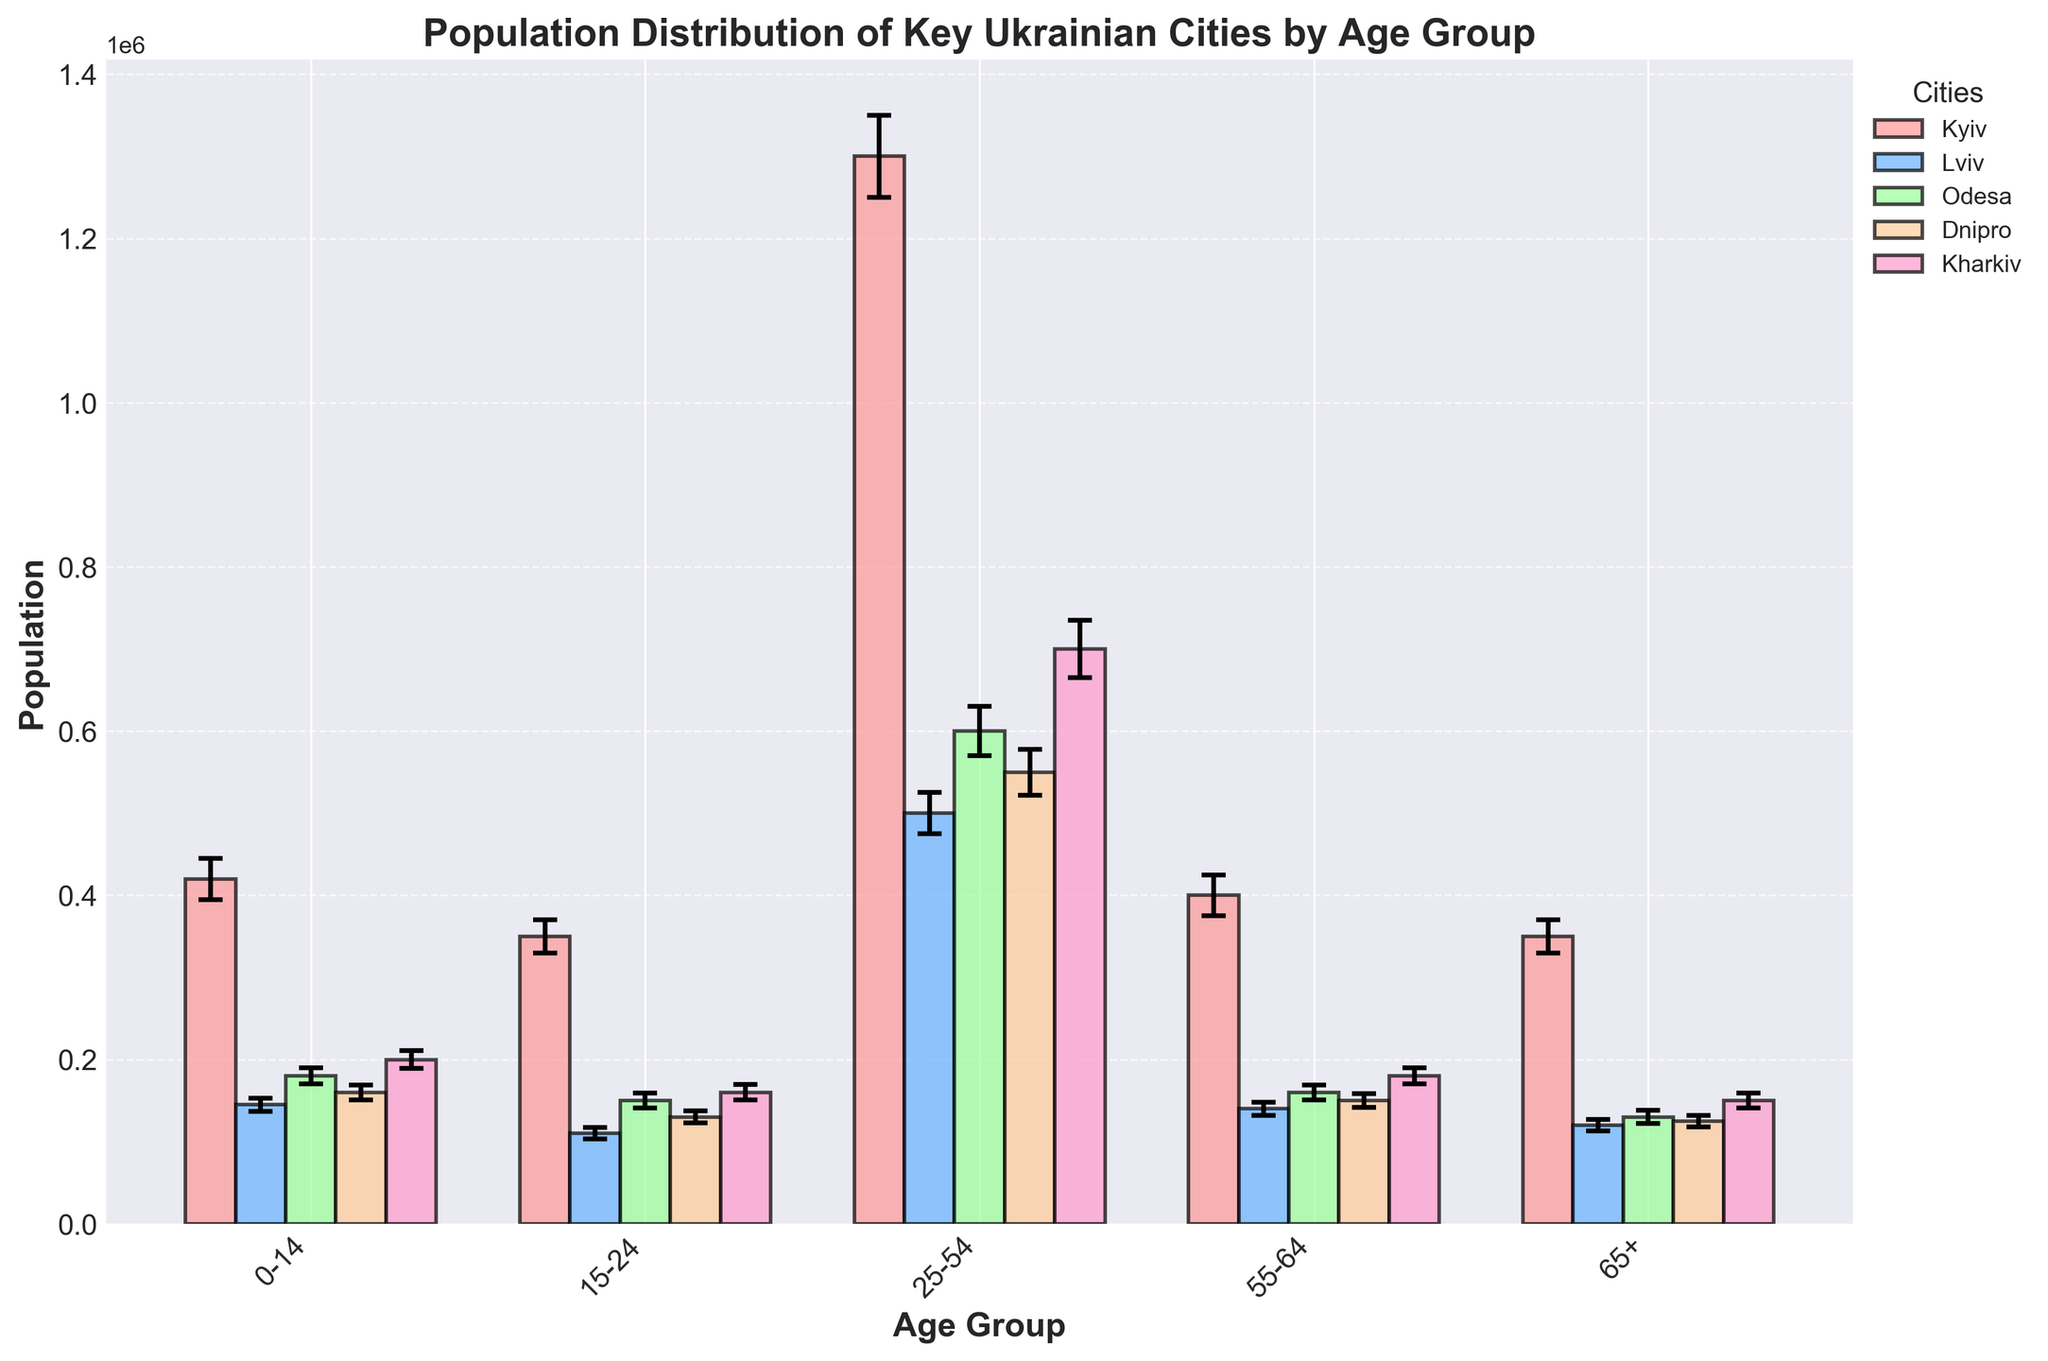what is the title of the plot? Look at the top center of the figure to find the title. The title is "Population Distribution of Key Ukrainian Cities by Age Group"
Answer: Population Distribution of Key Ukrainian Cities by Age Group How many cities are represented in the plot? Identify all unique labels in the legend on the right side of the figure. The cities represented are Kyiv, Lviv, Odesa, Dnipro, and Kharkiv
Answer: 5 Which age group in Kyiv has the highest population? Find the bar corresponding to Kyiv for each age group and compare their heights. The 25-54 age group bar is the tallest among all age groups for Kyiv
Answer: 25-54 Which city has the largest error margin for the 15-24 age group? Look at the error bars on the 15-24 age group across all cities. The largest error bar is for Kharkiv
Answer: Kharkiv What is the approximate population of the 0-14 age group in Lviv? Locate the bar representing Lviv for the 0-14 age group, near the left side of the figure. The height of the bar indicates a population around 145,000
Answer: 145,000 Compare the population of the 55-64 age group between Dnipro and Odesa. Which city has a larger population for this age group? Observe and compare the heights of the bars for the 55-64 age group for both Dnipro and Odesa. Dnipro's bar is lower than Odesa's
Answer: Odesa What is the total population of the 65+ age group across Kyiv and Lviv? Add the populations for the 65+ age group for Kyiv (350,000) and Lviv (120,000). The total is 350,000 + 120,000 = 470,000
Answer: 470,000 Of the cities presented, which one has the smallest population for the 25-54 age group? Locate the bars for the 25-54 age group for all cities and identify which is the shortest bar. Lviv has the smallest population bar for this age group
Answer: Lviv What color is used to represent Kharkiv in the plot? Refer to the legend on the right side of the figure and match the color with Kharkiv. Kharkiv is represented by the purple color
Answer: purple 